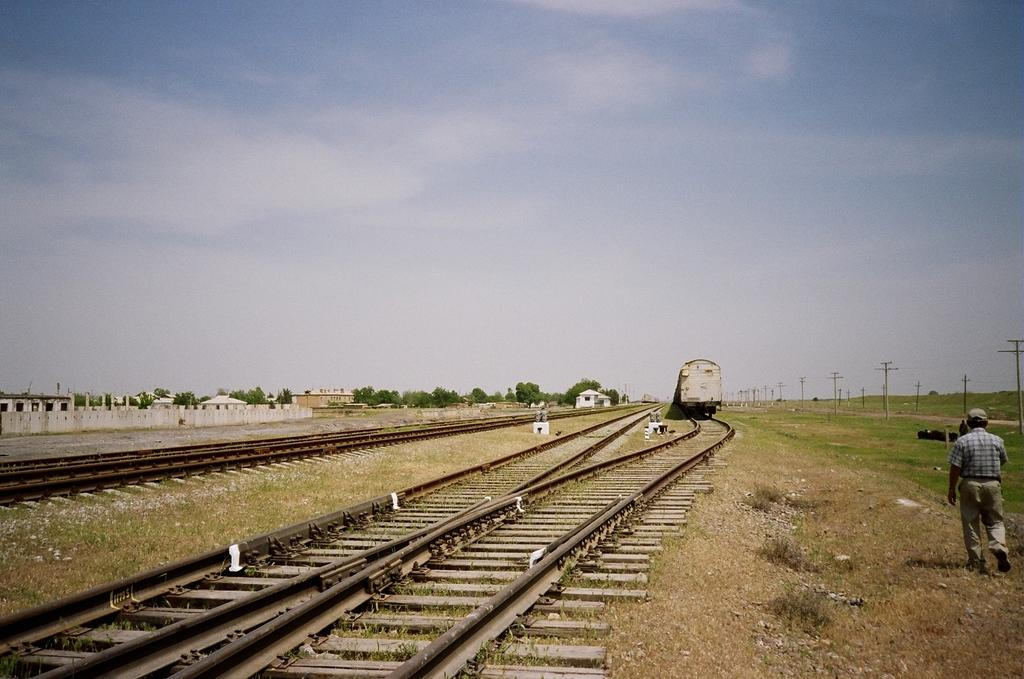What is the main subject of the image? The main subject of the image is a train on the track. What is the man in the image doing? The man is walking. What type of vegetation can be seen in the image? There are trees and grass visible in the image. What is visible in the background of the image? The sky is visible in the image. What is the train located on in the image? The train is on the tracks in the image. What type of book is the train distributing in the image? There is no book or distribution activity present in the image; it features a train on the tracks and a man walking. 